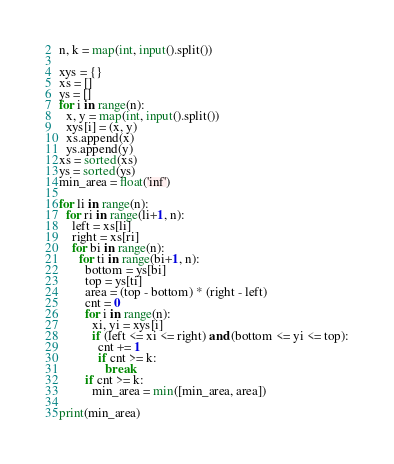Convert code to text. <code><loc_0><loc_0><loc_500><loc_500><_Python_>n, k = map(int, input().split())

xys = {}
xs = []
ys = []
for i in range(n):
  x, y = map(int, input().split())
  xys[i] = (x, y)
  xs.append(x)
  ys.append(y)
xs = sorted(xs)
ys = sorted(ys)
min_area = float('inf')

for li in range(n):
  for ri in range(li+1, n):
    left = xs[li]
    right = xs[ri]
    for bi in range(n):
      for ti in range(bi+1, n):
        bottom = ys[bi]
        top = ys[ti]
        area = (top - bottom) * (right - left)
        cnt = 0
        for i in range(n):
          xi, yi = xys[i]
          if (left <= xi <= right) and (bottom <= yi <= top):
            cnt += 1
            if cnt >= k:
              break
        if cnt >= k:
          min_area = min([min_area, area])

print(min_area)
</code> 